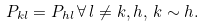Convert formula to latex. <formula><loc_0><loc_0><loc_500><loc_500>P _ { k l } = P _ { h l } \, \forall \, l \neq k , h , \, k \sim h .</formula> 